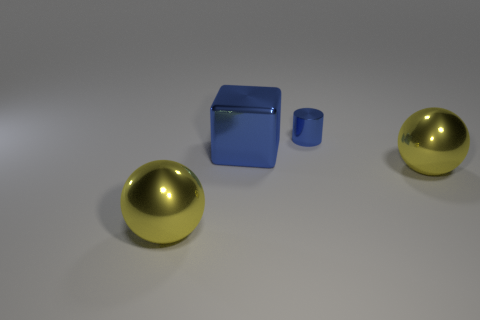Add 1 big yellow matte cylinders. How many objects exist? 5 Subtract all blocks. How many objects are left? 3 Subtract all metallic spheres. Subtract all large metal cubes. How many objects are left? 1 Add 1 shiny cylinders. How many shiny cylinders are left? 2 Add 2 yellow spheres. How many yellow spheres exist? 4 Subtract 0 gray spheres. How many objects are left? 4 